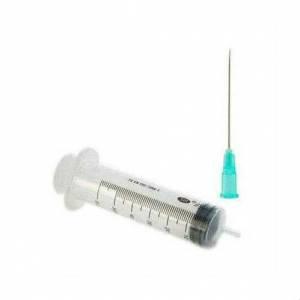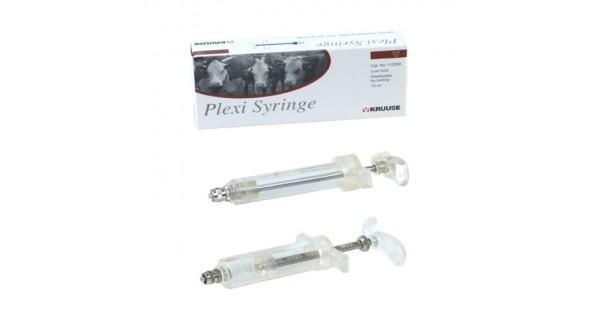The first image is the image on the left, the second image is the image on the right. Considering the images on both sides, is "At least one image contains exactly four syringes, and no image contains less than four syringes." valid? Answer yes or no. No. The first image is the image on the left, the second image is the image on the right. Analyze the images presented: Is the assertion "In at least one image there is a single empty needle laying down." valid? Answer yes or no. Yes. 